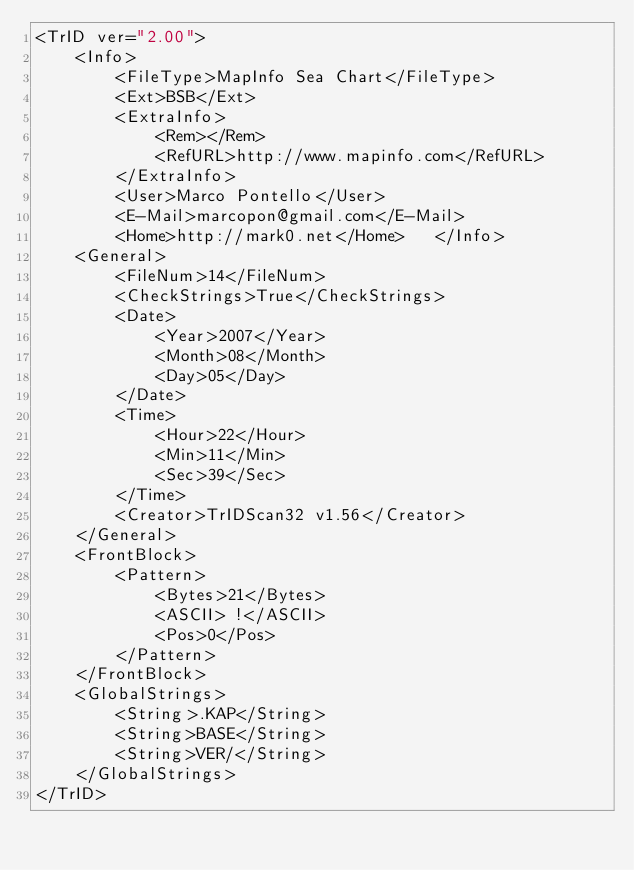<code> <loc_0><loc_0><loc_500><loc_500><_XML_><TrID ver="2.00">
	<Info>
		<FileType>MapInfo Sea Chart</FileType>
		<Ext>BSB</Ext>
		<ExtraInfo>
			<Rem></Rem>
			<RefURL>http://www.mapinfo.com</RefURL>
		</ExtraInfo>
		<User>Marco Pontello</User>
		<E-Mail>marcopon@gmail.com</E-Mail>
		<Home>http://mark0.net</Home>	</Info>
	<General>
		<FileNum>14</FileNum>
		<CheckStrings>True</CheckStrings>
		<Date>
			<Year>2007</Year>
			<Month>08</Month>
			<Day>05</Day>
		</Date>
		<Time>
			<Hour>22</Hour>
			<Min>11</Min>
			<Sec>39</Sec>
		</Time>
		<Creator>TrIDScan32 v1.56</Creator>
	</General>
	<FrontBlock>
		<Pattern>
			<Bytes>21</Bytes>
			<ASCII> !</ASCII>
			<Pos>0</Pos>
		</Pattern>
	</FrontBlock>
	<GlobalStrings>
		<String>.KAP</String>
		<String>BASE</String>
		<String>VER/</String>
	</GlobalStrings>
</TrID>
</code> 